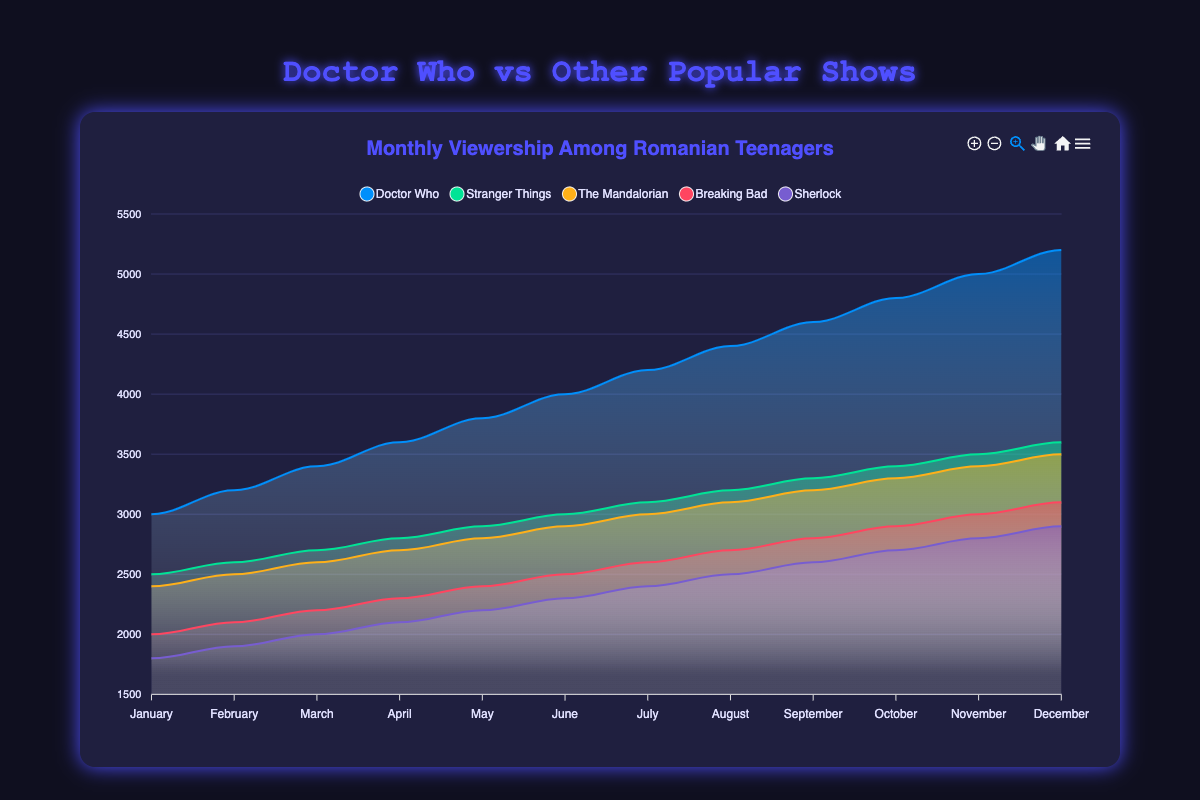Which month had the highest viewership for Doctor Who? By looking at the area chart for Doctor Who, we see that the highest point occurs in December, corresponding to the value 5200.
Answer: December What is the difference in viewership between Doctor Who and Stranger Things in June? According to the chart, the viewership for Doctor Who in June is 4000, and for Stranger Things, it's 3000. The difference is 4000 - 3000 = 1000.
Answer: 1000 Which TV show had the lowest viewership in January? By examining the area chart, Sherlock has the lowest viewership in January, with 1800 viewers.
Answer: Sherlock What is the average monthly viewership for Breaking Bad? To find the average, we sum up the monthly viewership values (2000, 2100, 2200, 2300, 2400, 2500, 2600, 2700, 2800, 2900, 3000, 3100) which equals 31200, then divide by 12 (31200 / 12).
Answer: 2600 How does the viewership growth of Doctor Who from January to December compare to Sherlock? Doctor Who grows from 3000 in January to 5200 in December, an increase of 5200 - 3000 = 2200. Sherlock grows from 1800 in January to 2900 in December, an increase of 2900 - 1800 = 1100.
Answer: Doctor Who has greater growth Which month has the smallest difference in viewership between The Mandalorian and Stranger Things? Checking each month on the chart, the smallest difference happens in January, where The Mandalorian has 2400 and Stranger Things has 2500, a difference of 100.
Answer: January In how many months does Doctor Who have a higher viewership than all the other shows? By scanning each month in the chart, Doctor Who has higher viewership than all other shows in every month.
Answer: 12 months What is the combined viewership of Doctor Who and The Mandalorian in September? For September, the viewership values are 4600 for Doctor Who and 3200 for The Mandalorian. Adding these together gives 4600 + 3200 = 7800.
Answer: 7800 Which show has the most consistent (least fluctuating) viewership trend over the year? Observing the areas, Breaking Bad shows the most consistent trend as the viewership increases steadily, with smaller increments.
Answer: Breaking Bad What is the total viewership for Stranger Things over the year? Adding up the twelve monthly values for Stranger Things (2500, 2600, 2700, 2800, 2900, 3000, 3100, 3200, 3300, 3400, 3500, 3600), we get a total of 38600.
Answer: 38600 